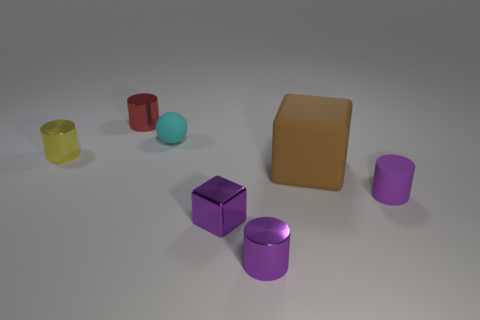Is there a rubber cylinder that has the same color as the small metal block?
Your response must be concise. Yes. Are there any other things that have the same size as the brown rubber block?
Give a very brief answer. No. There is a small block that is the same color as the matte cylinder; what material is it?
Your response must be concise. Metal. There is a tiny metallic thing that is behind the object that is to the left of the cylinder that is behind the small yellow cylinder; what is its shape?
Keep it short and to the point. Cylinder. How many other purple cubes are made of the same material as the big cube?
Your response must be concise. 0. How many red things are in front of the small metallic cylinder behind the yellow metal object?
Make the answer very short. 0. How many small cyan things are there?
Offer a very short reply. 1. Are the red cylinder and the block that is to the left of the brown matte block made of the same material?
Provide a succinct answer. Yes. Does the thing on the right side of the brown rubber object have the same color as the metal block?
Your answer should be compact. Yes. What material is the tiny cylinder that is to the left of the purple matte thing and in front of the small yellow cylinder?
Offer a terse response. Metal. 